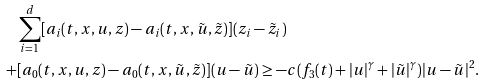Convert formula to latex. <formula><loc_0><loc_0><loc_500><loc_500>& \sum _ { i = 1 } ^ { d } [ a _ { i } ( t , x , u , z ) - a _ { i } ( t , x , \tilde { u } , \tilde { z } ) ] ( z _ { i } - \tilde { z } _ { i } ) \\ + & [ a _ { 0 } ( t , x , u , z ) - a _ { 0 } ( t , x , \tilde { u } , \tilde { z } ) ] ( u - \tilde { u } ) \geq - c ( f _ { 3 } ( t ) + | u | ^ { \gamma } + | \tilde { u } | ^ { \gamma } ) | u - \tilde { u } | ^ { 2 } .</formula> 